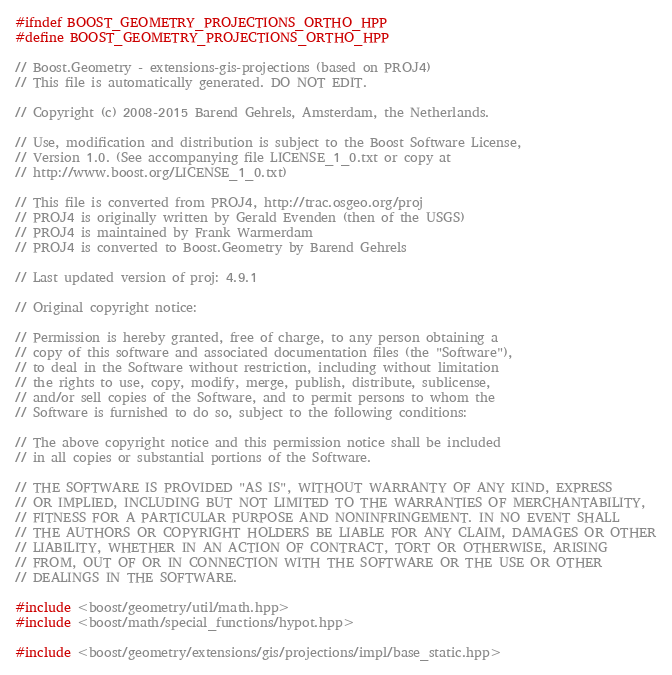Convert code to text. <code><loc_0><loc_0><loc_500><loc_500><_C++_>#ifndef BOOST_GEOMETRY_PROJECTIONS_ORTHO_HPP
#define BOOST_GEOMETRY_PROJECTIONS_ORTHO_HPP

// Boost.Geometry - extensions-gis-projections (based on PROJ4)
// This file is automatically generated. DO NOT EDIT.

// Copyright (c) 2008-2015 Barend Gehrels, Amsterdam, the Netherlands.

// Use, modification and distribution is subject to the Boost Software License,
// Version 1.0. (See accompanying file LICENSE_1_0.txt or copy at
// http://www.boost.org/LICENSE_1_0.txt)

// This file is converted from PROJ4, http://trac.osgeo.org/proj
// PROJ4 is originally written by Gerald Evenden (then of the USGS)
// PROJ4 is maintained by Frank Warmerdam
// PROJ4 is converted to Boost.Geometry by Barend Gehrels

// Last updated version of proj: 4.9.1

// Original copyright notice:

// Permission is hereby granted, free of charge, to any person obtaining a
// copy of this software and associated documentation files (the "Software"),
// to deal in the Software without restriction, including without limitation
// the rights to use, copy, modify, merge, publish, distribute, sublicense,
// and/or sell copies of the Software, and to permit persons to whom the
// Software is furnished to do so, subject to the following conditions:

// The above copyright notice and this permission notice shall be included
// in all copies or substantial portions of the Software.

// THE SOFTWARE IS PROVIDED "AS IS", WITHOUT WARRANTY OF ANY KIND, EXPRESS
// OR IMPLIED, INCLUDING BUT NOT LIMITED TO THE WARRANTIES OF MERCHANTABILITY,
// FITNESS FOR A PARTICULAR PURPOSE AND NONINFRINGEMENT. IN NO EVENT SHALL
// THE AUTHORS OR COPYRIGHT HOLDERS BE LIABLE FOR ANY CLAIM, DAMAGES OR OTHER
// LIABILITY, WHETHER IN AN ACTION OF CONTRACT, TORT OR OTHERWISE, ARISING
// FROM, OUT OF OR IN CONNECTION WITH THE SOFTWARE OR THE USE OR OTHER
// DEALINGS IN THE SOFTWARE.

#include <boost/geometry/util/math.hpp>
#include <boost/math/special_functions/hypot.hpp>

#include <boost/geometry/extensions/gis/projections/impl/base_static.hpp></code> 